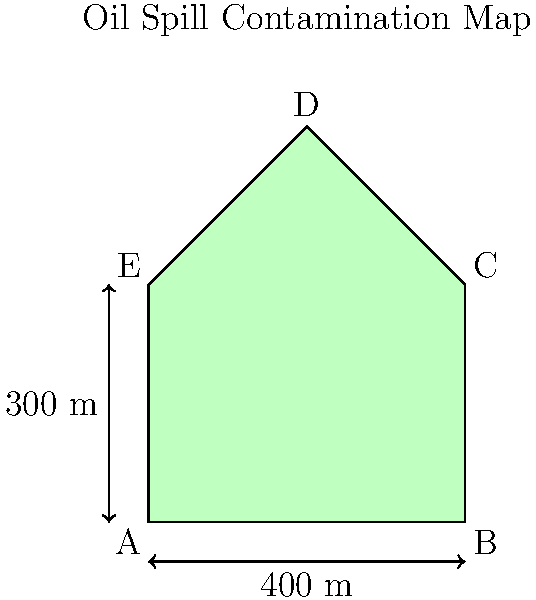Based on the oil spill contamination map above, estimate the volume of the oil spill if the average depth of contamination is 0.15 meters. Assume the contaminated area can be approximated as a polygon ABCDE. To calculate the volume of the oil spill, we need to follow these steps:

1. Calculate the area of the contaminated region (polygon ABCDE).
2. Multiply the area by the average depth of contamination.

Step 1: Calculating the area of polygon ABCDE

We can divide the polygon into a rectangle and a triangle:
- Rectangle ABCE: 400 m × 300 m = 120,000 m²
- Triangle CDE: base = 200 m, height = 200 m
  Area of triangle = $\frac{1}{2} \times 200 \text{ m} \times 200 \text{ m} = 20,000 \text{ m}^2$

Total area = Area of rectangle + Area of triangle
           = 120,000 m² + 20,000 m² = 140,000 m²

Step 2: Calculating the volume

Volume = Area × Average depth
       = 140,000 m² × 0.15 m
       = 21,000 m³

Therefore, the estimated volume of the oil spill is 21,000 cubic meters.
Answer: 21,000 m³ 